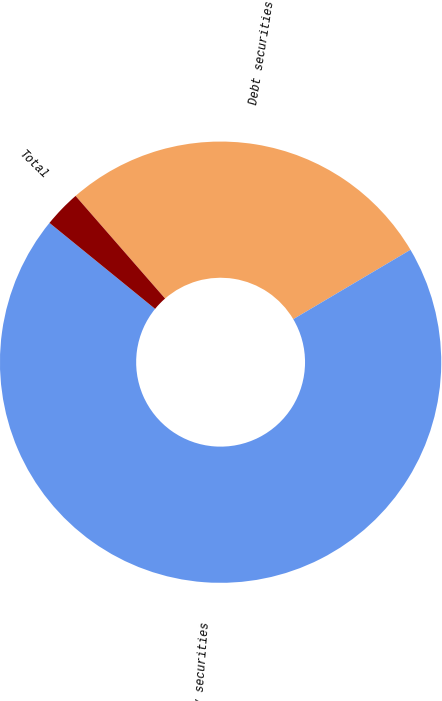Convert chart. <chart><loc_0><loc_0><loc_500><loc_500><pie_chart><fcel>Debt securities<fcel>Equity securities<fcel>Total<nl><fcel>27.91%<fcel>69.38%<fcel>2.71%<nl></chart> 